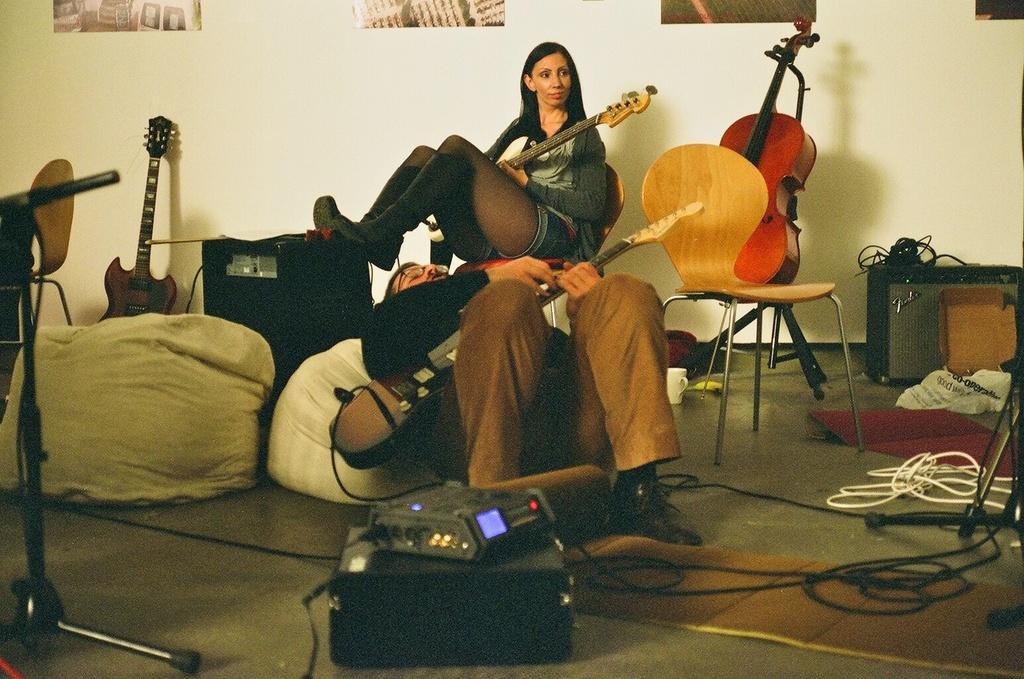In one or two sentences, can you explain what this image depicts? In this image I can see a woman is sitting on a chair and holding a guitar in her hand and a person wearing black shirt, brown pant and black shoe is laying on a white colored object and holding a guitar in his hands. I can see a red colored guitar, a chair, few wires, few electronic equipments on the floor. In the background I can see the white colored wall and few posts attached to the wall. 